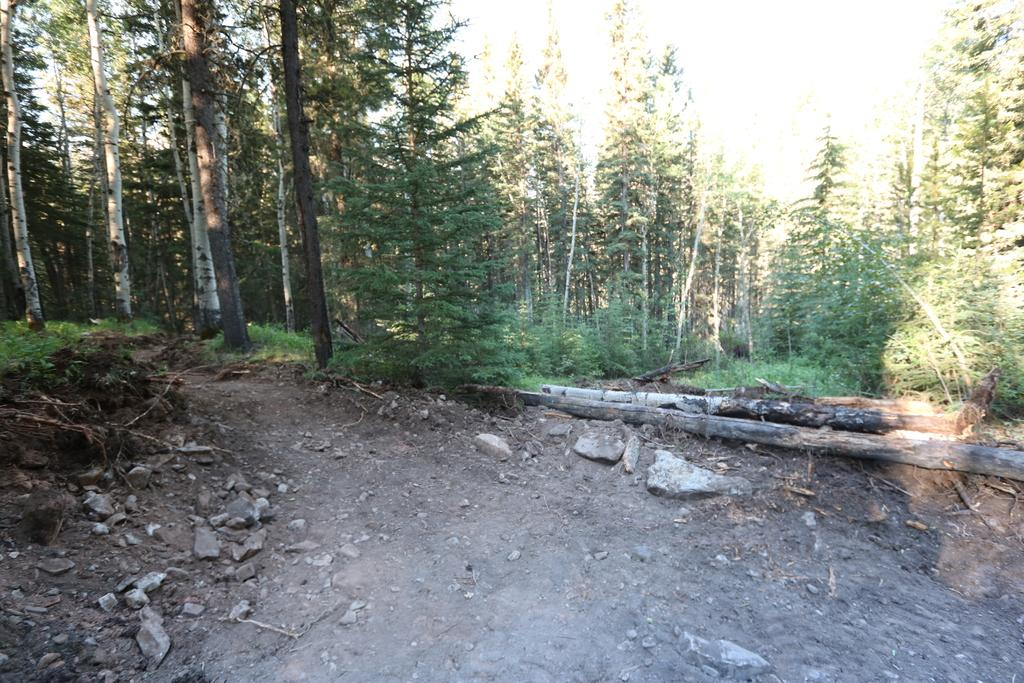What type of natural elements can be seen in the image? There are stones, grass, and trees in the image. What type of man-made objects are present in the image? There are wooden objects in the image. What is visible in the background of the image? The sky is visible in the image. What type of card is being used to make popcorn in the image? There is no card or popcorn present in the image. What type of brick is visible in the image? There is no brick present in the image. 